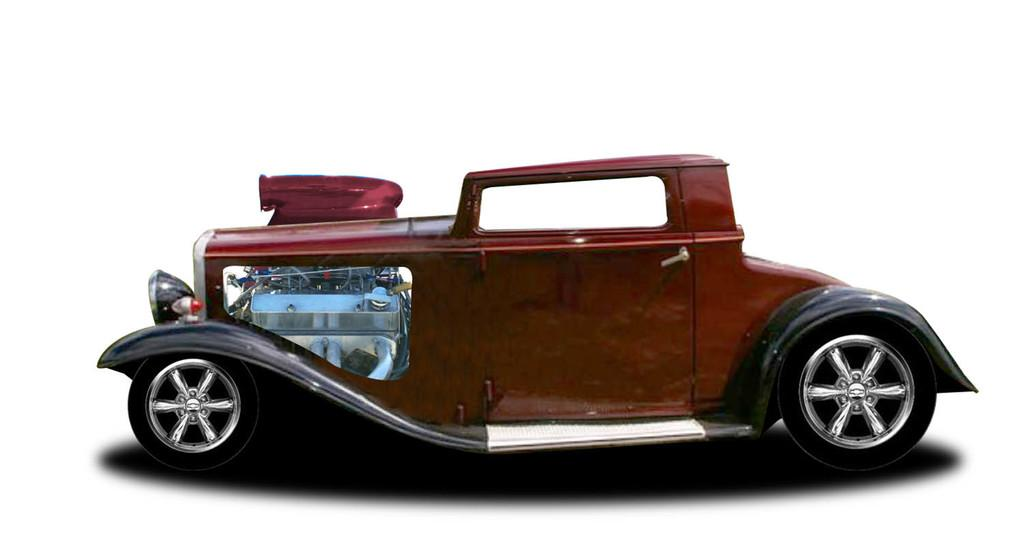What is the main subject of the image? The main subject of the image is a car. Can you describe the background of the image? There is a white surface visible in the backdrop of the image. What type of pizzas are being served at the event in the image? There is no event or pizzas present in the image; it features a car and a white surface in the background. 